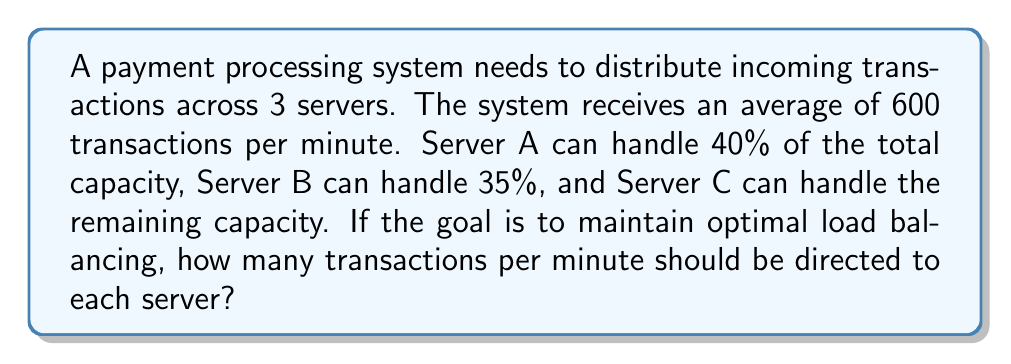Show me your answer to this math problem. Let's approach this step-by-step:

1) First, let's define our variables:
   $x$ = transactions per minute for Server A
   $y$ = transactions per minute for Server B
   $z$ = transactions per minute for Server C

2) We know the total transactions per minute is 600, so:
   $$x + y + z = 600$$

3) We're given the capacity percentages for each server:
   Server A: 40% = 0.4
   Server B: 35% = 0.35
   Server C: 25% = 0.25 (remaining capacity)

4) For optimal load balancing, each server should handle transactions proportional to its capacity:
   $$\frac{x}{0.4} = \frac{y}{0.35} = \frac{z}{0.25} = 600$$

5) From this, we can set up equations:
   $$x = 0.4 * 600 = 240$$
   $$y = 0.35 * 600 = 210$$
   $$z = 0.25 * 600 = 150$$

6) Let's verify that these values sum to 600:
   $$240 + 210 + 150 = 600$$

Therefore, for optimal load balancing:
Server A should handle 240 transactions per minute
Server B should handle 210 transactions per minute
Server C should handle 150 transactions per minute
Answer: Server A: 240 tpm, Server B: 210 tpm, Server C: 150 tpm 